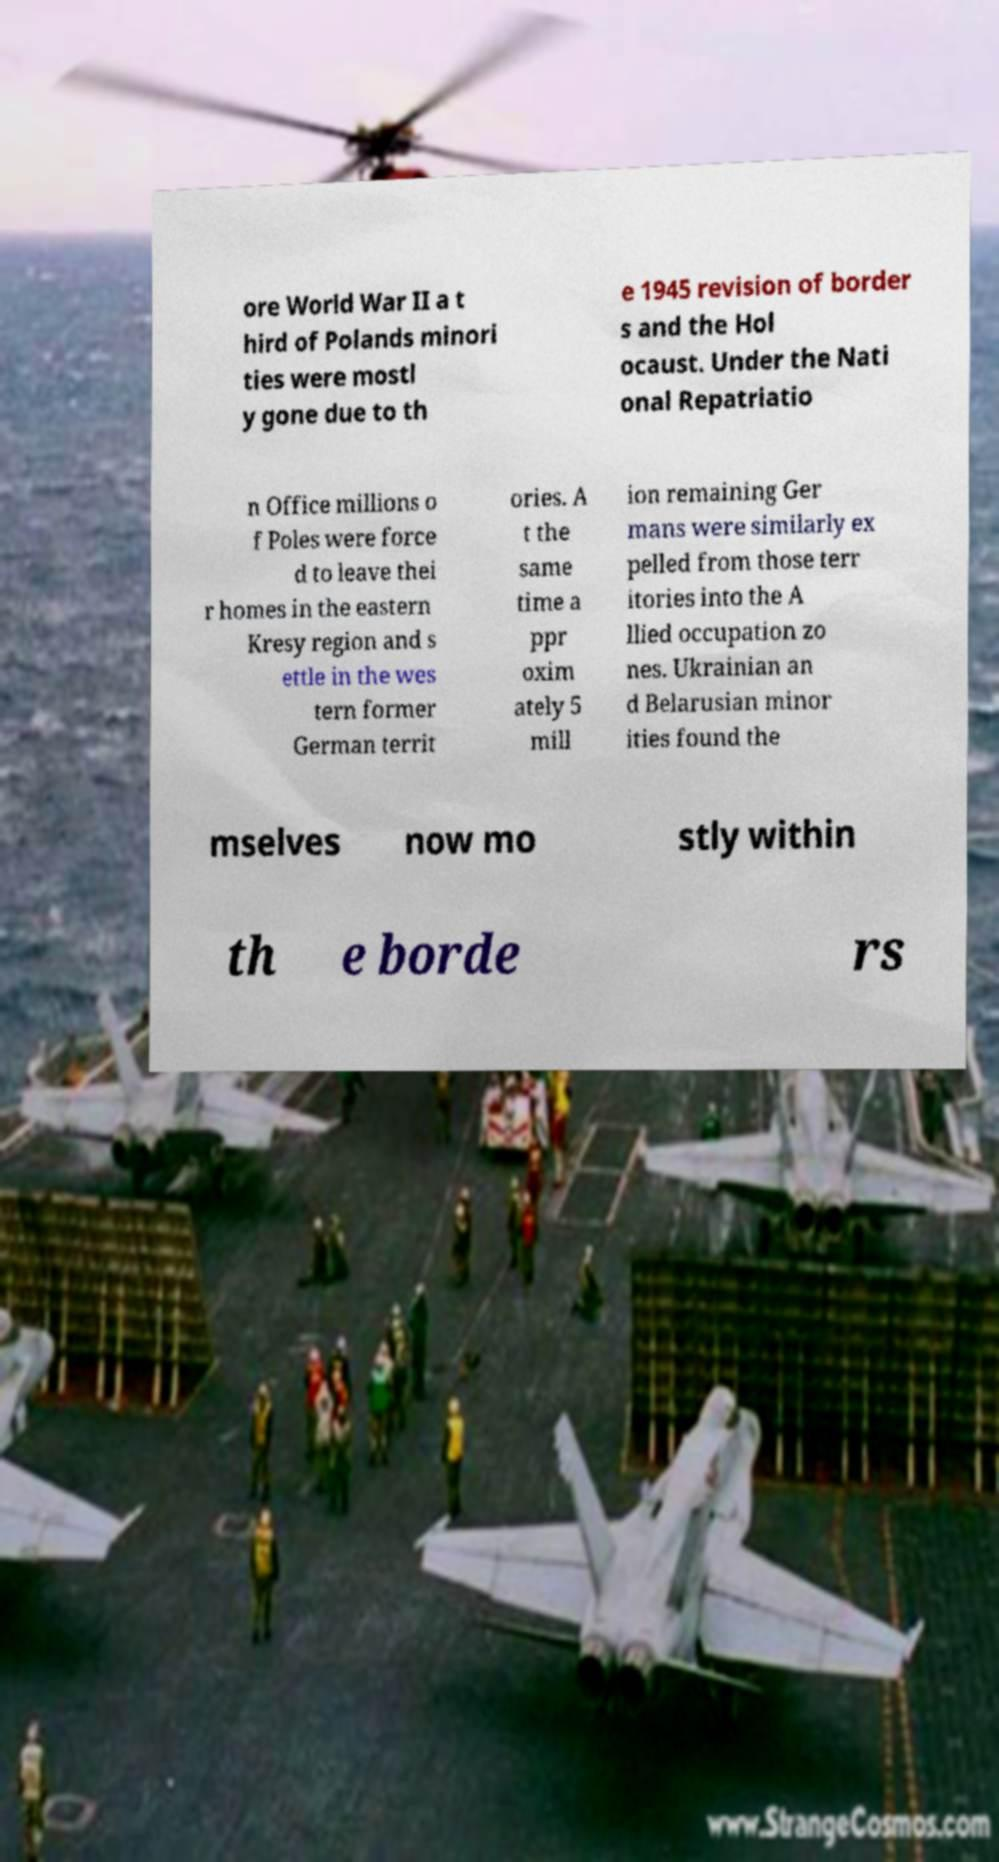For documentation purposes, I need the text within this image transcribed. Could you provide that? ore World War II a t hird of Polands minori ties were mostl y gone due to th e 1945 revision of border s and the Hol ocaust. Under the Nati onal Repatriatio n Office millions o f Poles were force d to leave thei r homes in the eastern Kresy region and s ettle in the wes tern former German territ ories. A t the same time a ppr oxim ately 5 mill ion remaining Ger mans were similarly ex pelled from those terr itories into the A llied occupation zo nes. Ukrainian an d Belarusian minor ities found the mselves now mo stly within th e borde rs 